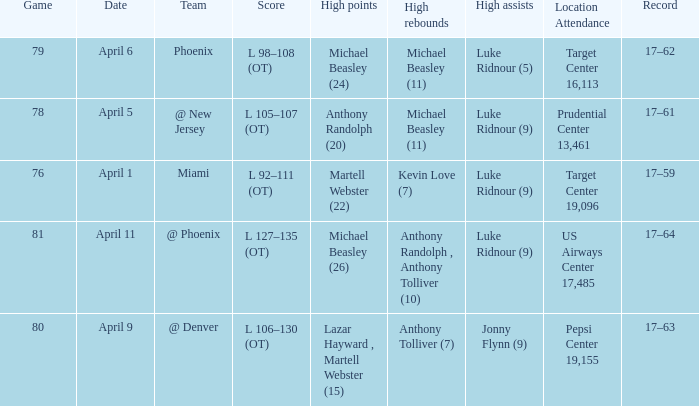Who did the most high rebounds on April 6? Michael Beasley (11). 